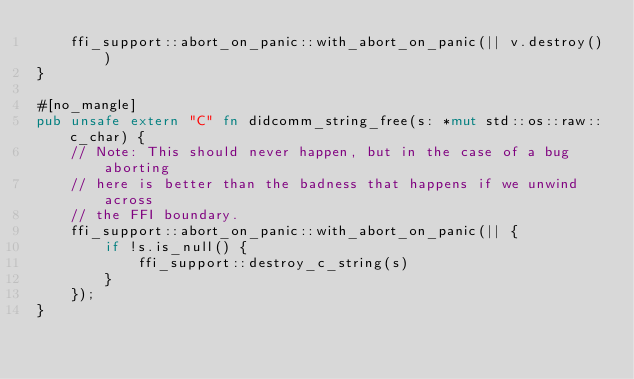<code> <loc_0><loc_0><loc_500><loc_500><_Rust_>    ffi_support::abort_on_panic::with_abort_on_panic(|| v.destroy())
}

#[no_mangle]
pub unsafe extern "C" fn didcomm_string_free(s: *mut std::os::raw::c_char) {
    // Note: This should never happen, but in the case of a bug aborting
    // here is better than the badness that happens if we unwind across
    // the FFI boundary.
    ffi_support::abort_on_panic::with_abort_on_panic(|| {
        if !s.is_null() {
            ffi_support::destroy_c_string(s)
        }
    });
}
</code> 